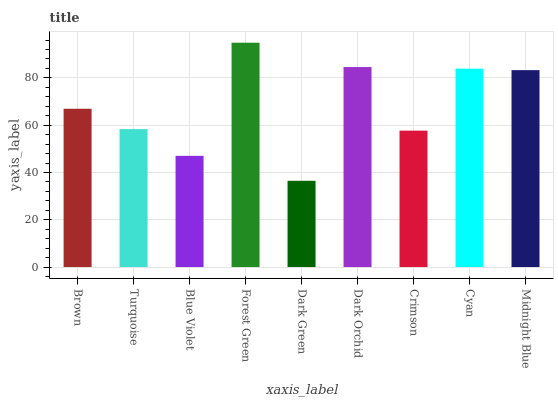Is Turquoise the minimum?
Answer yes or no. No. Is Turquoise the maximum?
Answer yes or no. No. Is Brown greater than Turquoise?
Answer yes or no. Yes. Is Turquoise less than Brown?
Answer yes or no. Yes. Is Turquoise greater than Brown?
Answer yes or no. No. Is Brown less than Turquoise?
Answer yes or no. No. Is Brown the high median?
Answer yes or no. Yes. Is Brown the low median?
Answer yes or no. Yes. Is Dark Orchid the high median?
Answer yes or no. No. Is Forest Green the low median?
Answer yes or no. No. 